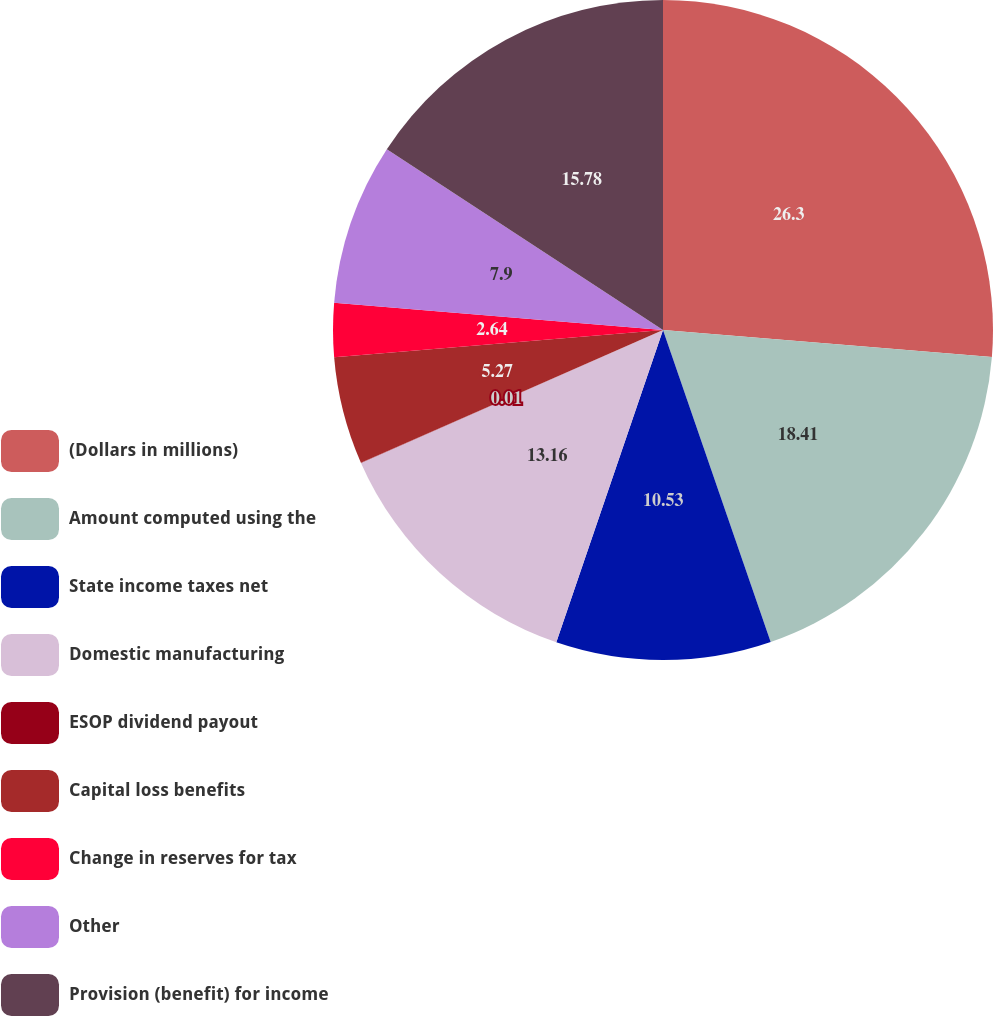Convert chart to OTSL. <chart><loc_0><loc_0><loc_500><loc_500><pie_chart><fcel>(Dollars in millions)<fcel>Amount computed using the<fcel>State income taxes net<fcel>Domestic manufacturing<fcel>ESOP dividend payout<fcel>Capital loss benefits<fcel>Change in reserves for tax<fcel>Other<fcel>Provision (benefit) for income<nl><fcel>26.3%<fcel>18.41%<fcel>10.53%<fcel>13.16%<fcel>0.01%<fcel>5.27%<fcel>2.64%<fcel>7.9%<fcel>15.78%<nl></chart> 